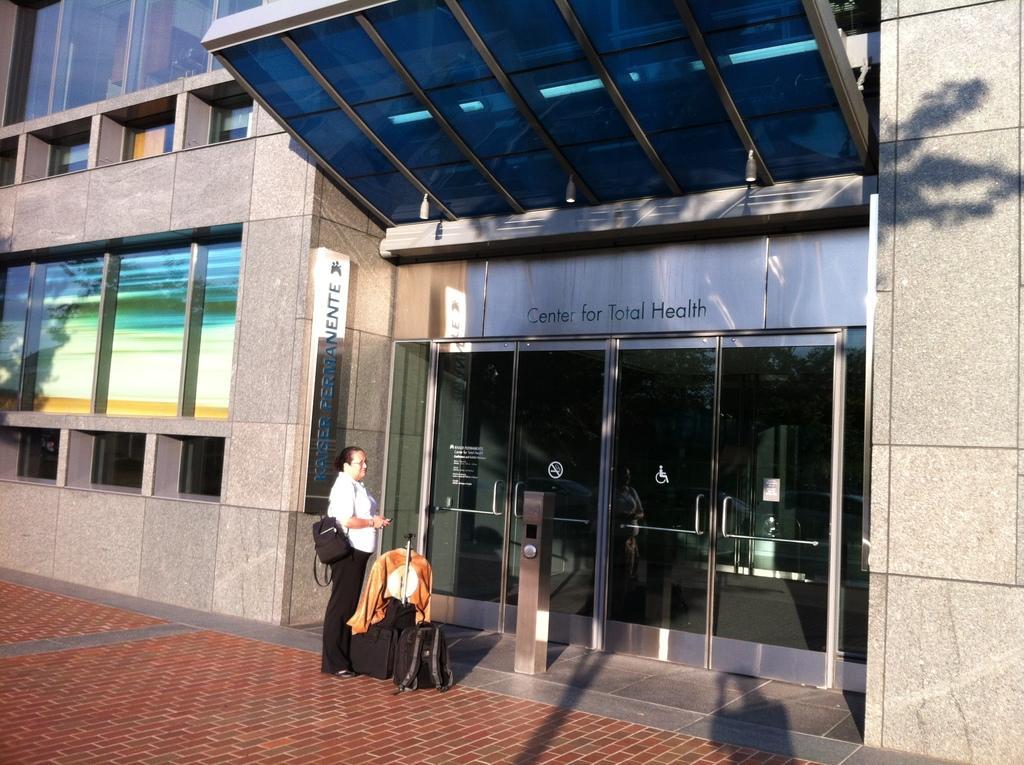In one or two sentences, can you explain what this image depicts? We can see a building, glass windows and glass doors. In-front of this building a person is standing. Beside this person there is a luggage and bag. 